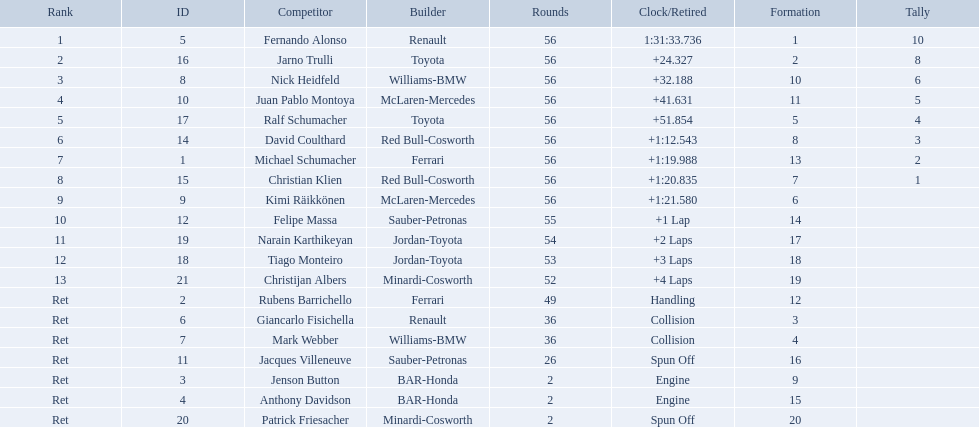Who raced during the 2005 malaysian grand prix? Fernando Alonso, Jarno Trulli, Nick Heidfeld, Juan Pablo Montoya, Ralf Schumacher, David Coulthard, Michael Schumacher, Christian Klien, Kimi Räikkönen, Felipe Massa, Narain Karthikeyan, Tiago Monteiro, Christijan Albers, Rubens Barrichello, Giancarlo Fisichella, Mark Webber, Jacques Villeneuve, Jenson Button, Anthony Davidson, Patrick Friesacher. What were their finishing times? 1:31:33.736, +24.327, +32.188, +41.631, +51.854, +1:12.543, +1:19.988, +1:20.835, +1:21.580, +1 Lap, +2 Laps, +3 Laps, +4 Laps, Handling, Collision, Collision, Spun Off, Engine, Engine, Spun Off. What was fernando alonso's finishing time? 1:31:33.736. Can you give me this table in json format? {'header': ['Rank', 'ID', 'Competitor', 'Builder', 'Rounds', 'Clock/Retired', 'Formation', 'Tally'], 'rows': [['1', '5', 'Fernando Alonso', 'Renault', '56', '1:31:33.736', '1', '10'], ['2', '16', 'Jarno Trulli', 'Toyota', '56', '+24.327', '2', '8'], ['3', '8', 'Nick Heidfeld', 'Williams-BMW', '56', '+32.188', '10', '6'], ['4', '10', 'Juan Pablo Montoya', 'McLaren-Mercedes', '56', '+41.631', '11', '5'], ['5', '17', 'Ralf Schumacher', 'Toyota', '56', '+51.854', '5', '4'], ['6', '14', 'David Coulthard', 'Red Bull-Cosworth', '56', '+1:12.543', '8', '3'], ['7', '1', 'Michael Schumacher', 'Ferrari', '56', '+1:19.988', '13', '2'], ['8', '15', 'Christian Klien', 'Red Bull-Cosworth', '56', '+1:20.835', '7', '1'], ['9', '9', 'Kimi Räikkönen', 'McLaren-Mercedes', '56', '+1:21.580', '6', ''], ['10', '12', 'Felipe Massa', 'Sauber-Petronas', '55', '+1 Lap', '14', ''], ['11', '19', 'Narain Karthikeyan', 'Jordan-Toyota', '54', '+2 Laps', '17', ''], ['12', '18', 'Tiago Monteiro', 'Jordan-Toyota', '53', '+3 Laps', '18', ''], ['13', '21', 'Christijan Albers', 'Minardi-Cosworth', '52', '+4 Laps', '19', ''], ['Ret', '2', 'Rubens Barrichello', 'Ferrari', '49', 'Handling', '12', ''], ['Ret', '6', 'Giancarlo Fisichella', 'Renault', '36', 'Collision', '3', ''], ['Ret', '7', 'Mark Webber', 'Williams-BMW', '36', 'Collision', '4', ''], ['Ret', '11', 'Jacques Villeneuve', 'Sauber-Petronas', '26', 'Spun Off', '16', ''], ['Ret', '3', 'Jenson Button', 'BAR-Honda', '2', 'Engine', '9', ''], ['Ret', '4', 'Anthony Davidson', 'BAR-Honda', '2', 'Engine', '15', ''], ['Ret', '20', 'Patrick Friesacher', 'Minardi-Cosworth', '2', 'Spun Off', '20', '']]} 